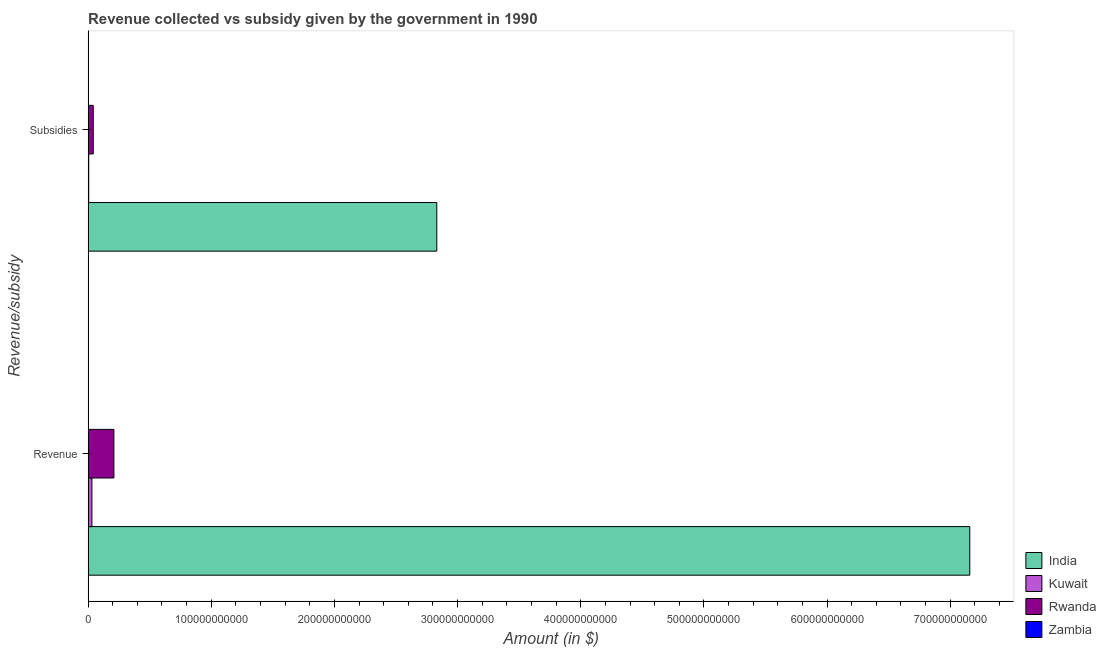How many groups of bars are there?
Ensure brevity in your answer.  2. Are the number of bars per tick equal to the number of legend labels?
Provide a succinct answer. Yes. What is the label of the 1st group of bars from the top?
Your answer should be very brief. Subsidies. What is the amount of revenue collected in Zambia?
Give a very brief answer. 2.31e+07. Across all countries, what is the maximum amount of revenue collected?
Offer a terse response. 7.16e+11. Across all countries, what is the minimum amount of revenue collected?
Your response must be concise. 2.31e+07. In which country was the amount of subsidies given maximum?
Offer a very short reply. India. In which country was the amount of revenue collected minimum?
Ensure brevity in your answer.  Zambia. What is the total amount of revenue collected in the graph?
Your answer should be compact. 7.40e+11. What is the difference between the amount of revenue collected in Rwanda and that in India?
Give a very brief answer. -6.95e+11. What is the difference between the amount of revenue collected in Kuwait and the amount of subsidies given in Zambia?
Provide a succinct answer. 3.11e+09. What is the average amount of subsidies given per country?
Offer a very short reply. 7.20e+1. What is the difference between the amount of subsidies given and amount of revenue collected in Kuwait?
Ensure brevity in your answer.  -2.59e+09. What is the ratio of the amount of subsidies given in India to that in Rwanda?
Give a very brief answer. 67.73. In how many countries, is the amount of revenue collected greater than the average amount of revenue collected taken over all countries?
Ensure brevity in your answer.  1. What does the 3rd bar from the top in Subsidies represents?
Your response must be concise. Kuwait. What does the 3rd bar from the bottom in Subsidies represents?
Make the answer very short. Rwanda. How many bars are there?
Provide a short and direct response. 8. What is the difference between two consecutive major ticks on the X-axis?
Offer a terse response. 1.00e+11. Where does the legend appear in the graph?
Your response must be concise. Bottom right. How many legend labels are there?
Your answer should be very brief. 4. What is the title of the graph?
Your response must be concise. Revenue collected vs subsidy given by the government in 1990. Does "Azerbaijan" appear as one of the legend labels in the graph?
Your answer should be very brief. No. What is the label or title of the X-axis?
Make the answer very short. Amount (in $). What is the label or title of the Y-axis?
Offer a very short reply. Revenue/subsidy. What is the Amount (in $) of India in Revenue?
Give a very brief answer. 7.16e+11. What is the Amount (in $) of Kuwait in Revenue?
Ensure brevity in your answer.  3.12e+09. What is the Amount (in $) of Rwanda in Revenue?
Your answer should be very brief. 2.10e+1. What is the Amount (in $) of Zambia in Revenue?
Give a very brief answer. 2.31e+07. What is the Amount (in $) in India in Subsidies?
Your response must be concise. 2.83e+11. What is the Amount (in $) in Kuwait in Subsidies?
Your answer should be very brief. 5.24e+08. What is the Amount (in $) of Rwanda in Subsidies?
Your answer should be very brief. 4.18e+09. What is the Amount (in $) of Zambia in Subsidies?
Offer a terse response. 2.83e+06. Across all Revenue/subsidy, what is the maximum Amount (in $) of India?
Provide a succinct answer. 7.16e+11. Across all Revenue/subsidy, what is the maximum Amount (in $) in Kuwait?
Give a very brief answer. 3.12e+09. Across all Revenue/subsidy, what is the maximum Amount (in $) in Rwanda?
Provide a short and direct response. 2.10e+1. Across all Revenue/subsidy, what is the maximum Amount (in $) of Zambia?
Keep it short and to the point. 2.31e+07. Across all Revenue/subsidy, what is the minimum Amount (in $) in India?
Ensure brevity in your answer.  2.83e+11. Across all Revenue/subsidy, what is the minimum Amount (in $) in Kuwait?
Your answer should be very brief. 5.24e+08. Across all Revenue/subsidy, what is the minimum Amount (in $) of Rwanda?
Your answer should be compact. 4.18e+09. Across all Revenue/subsidy, what is the minimum Amount (in $) in Zambia?
Offer a very short reply. 2.83e+06. What is the total Amount (in $) in India in the graph?
Offer a terse response. 9.99e+11. What is the total Amount (in $) of Kuwait in the graph?
Provide a succinct answer. 3.64e+09. What is the total Amount (in $) of Rwanda in the graph?
Offer a very short reply. 2.51e+1. What is the total Amount (in $) of Zambia in the graph?
Your answer should be compact. 2.60e+07. What is the difference between the Amount (in $) of India in Revenue and that in Subsidies?
Provide a succinct answer. 4.33e+11. What is the difference between the Amount (in $) in Kuwait in Revenue and that in Subsidies?
Your answer should be very brief. 2.59e+09. What is the difference between the Amount (in $) of Rwanda in Revenue and that in Subsidies?
Your response must be concise. 1.68e+1. What is the difference between the Amount (in $) in Zambia in Revenue and that in Subsidies?
Offer a very short reply. 2.03e+07. What is the difference between the Amount (in $) of India in Revenue and the Amount (in $) of Kuwait in Subsidies?
Your answer should be very brief. 7.15e+11. What is the difference between the Amount (in $) of India in Revenue and the Amount (in $) of Rwanda in Subsidies?
Offer a terse response. 7.12e+11. What is the difference between the Amount (in $) in India in Revenue and the Amount (in $) in Zambia in Subsidies?
Keep it short and to the point. 7.16e+11. What is the difference between the Amount (in $) in Kuwait in Revenue and the Amount (in $) in Rwanda in Subsidies?
Your answer should be compact. -1.06e+09. What is the difference between the Amount (in $) in Kuwait in Revenue and the Amount (in $) in Zambia in Subsidies?
Your response must be concise. 3.11e+09. What is the difference between the Amount (in $) of Rwanda in Revenue and the Amount (in $) of Zambia in Subsidies?
Your response must be concise. 2.10e+1. What is the average Amount (in $) in India per Revenue/subsidy?
Keep it short and to the point. 4.99e+11. What is the average Amount (in $) of Kuwait per Revenue/subsidy?
Offer a very short reply. 1.82e+09. What is the average Amount (in $) in Rwanda per Revenue/subsidy?
Offer a very short reply. 1.26e+1. What is the average Amount (in $) in Zambia per Revenue/subsidy?
Provide a succinct answer. 1.30e+07. What is the difference between the Amount (in $) in India and Amount (in $) in Kuwait in Revenue?
Ensure brevity in your answer.  7.13e+11. What is the difference between the Amount (in $) in India and Amount (in $) in Rwanda in Revenue?
Give a very brief answer. 6.95e+11. What is the difference between the Amount (in $) in India and Amount (in $) in Zambia in Revenue?
Your response must be concise. 7.16e+11. What is the difference between the Amount (in $) of Kuwait and Amount (in $) of Rwanda in Revenue?
Your answer should be compact. -1.78e+1. What is the difference between the Amount (in $) in Kuwait and Amount (in $) in Zambia in Revenue?
Provide a succinct answer. 3.09e+09. What is the difference between the Amount (in $) of Rwanda and Amount (in $) of Zambia in Revenue?
Provide a short and direct response. 2.09e+1. What is the difference between the Amount (in $) of India and Amount (in $) of Kuwait in Subsidies?
Ensure brevity in your answer.  2.83e+11. What is the difference between the Amount (in $) of India and Amount (in $) of Rwanda in Subsidies?
Your answer should be compact. 2.79e+11. What is the difference between the Amount (in $) in India and Amount (in $) in Zambia in Subsidies?
Provide a succinct answer. 2.83e+11. What is the difference between the Amount (in $) in Kuwait and Amount (in $) in Rwanda in Subsidies?
Keep it short and to the point. -3.66e+09. What is the difference between the Amount (in $) of Kuwait and Amount (in $) of Zambia in Subsidies?
Your answer should be very brief. 5.21e+08. What is the difference between the Amount (in $) in Rwanda and Amount (in $) in Zambia in Subsidies?
Provide a succinct answer. 4.18e+09. What is the ratio of the Amount (in $) of India in Revenue to that in Subsidies?
Give a very brief answer. 2.53. What is the ratio of the Amount (in $) in Kuwait in Revenue to that in Subsidies?
Provide a succinct answer. 5.95. What is the ratio of the Amount (in $) in Rwanda in Revenue to that in Subsidies?
Give a very brief answer. 5.01. What is the ratio of the Amount (in $) in Zambia in Revenue to that in Subsidies?
Your response must be concise. 8.18. What is the difference between the highest and the second highest Amount (in $) in India?
Provide a succinct answer. 4.33e+11. What is the difference between the highest and the second highest Amount (in $) of Kuwait?
Your answer should be very brief. 2.59e+09. What is the difference between the highest and the second highest Amount (in $) of Rwanda?
Offer a terse response. 1.68e+1. What is the difference between the highest and the second highest Amount (in $) of Zambia?
Offer a terse response. 2.03e+07. What is the difference between the highest and the lowest Amount (in $) of India?
Your response must be concise. 4.33e+11. What is the difference between the highest and the lowest Amount (in $) in Kuwait?
Your response must be concise. 2.59e+09. What is the difference between the highest and the lowest Amount (in $) in Rwanda?
Your response must be concise. 1.68e+1. What is the difference between the highest and the lowest Amount (in $) in Zambia?
Your answer should be compact. 2.03e+07. 